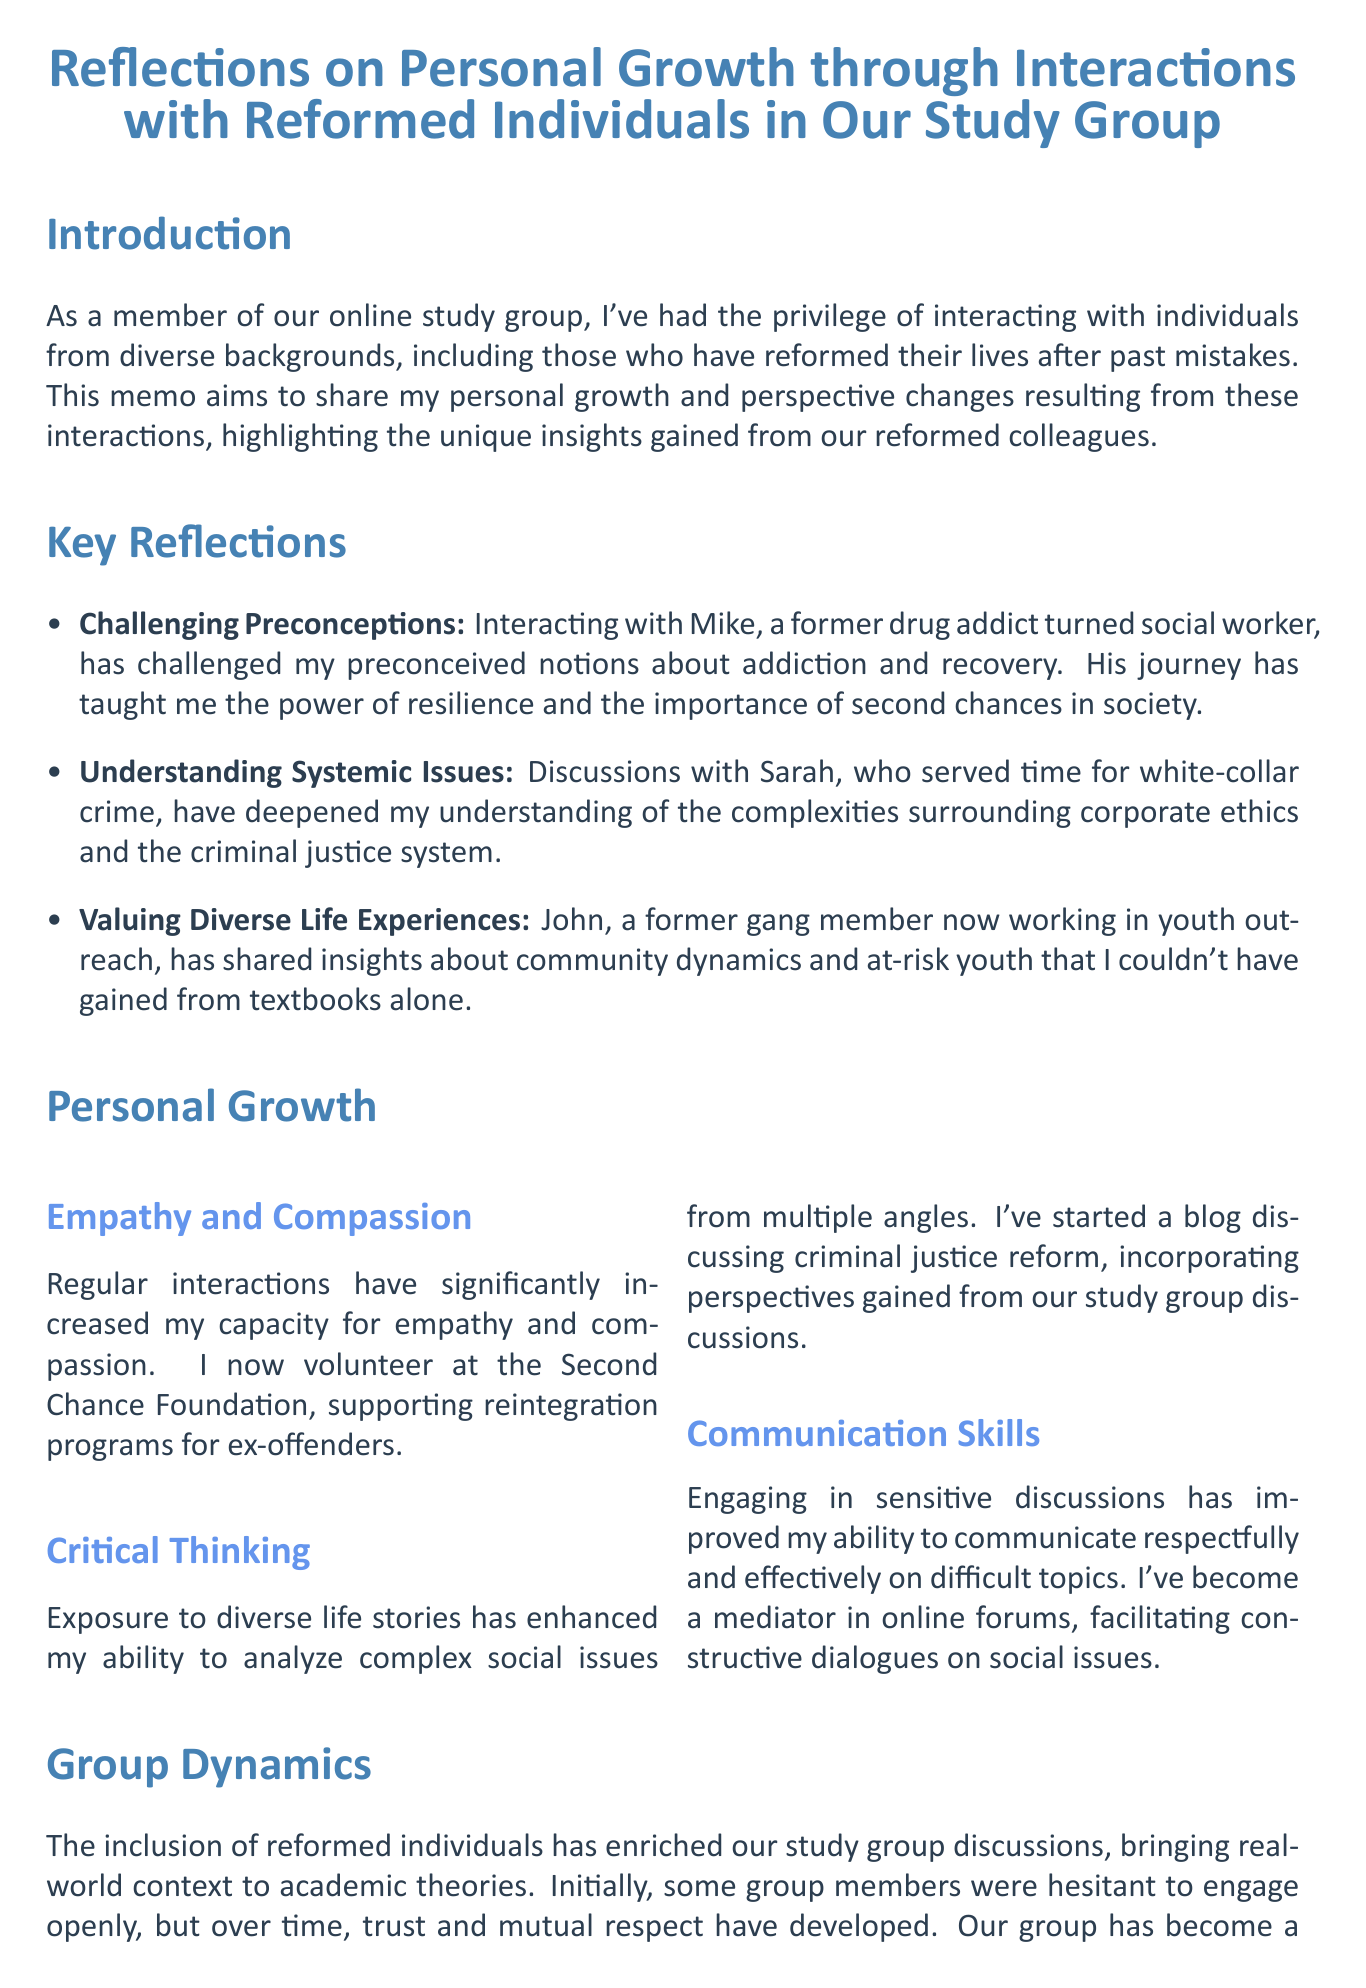What is the title of the memo? The title of the memo summarizes its focus on personal growth through interactions with reformed individuals.
Answer: Reflections on Personal Growth through Interactions with Reformed Individuals in Our Study Group Who is a former drug addict mentioned in the memo? Mike is introduced as a former drug addict turned social worker, highlighting his impact on the author's views.
Answer: Mike What is one area of personal growth discussed? The memo lists several areas of personal growth, one of which is increased empathy and compassion.
Answer: Empathy and Compassion Which group member served time for white-collar crime? Sarah's experiences with white-collar crime provide insights into corporate ethics and the justice system.
Answer: Sarah What is the positive impact of including reformed individuals in the study group? The inclusion of reformed individuals has brought real-world context to academic theories in discussions.
Answer: Enriched discussions What future commitment does the author express at the conclusion? The author expresses a commitment to continuing valuable interactions with reformed individuals.
Answer: Continuing these valuable interactions What example of increased communication skills is mentioned? The author states they have become a mediator in online forums, indicating improvement in communication.
Answer: Mediator in online forums What was a challenge faced by the group initially? The memo notes that some group members were hesitant to engage openly at first.
Answer: Hesitant to engage openly 